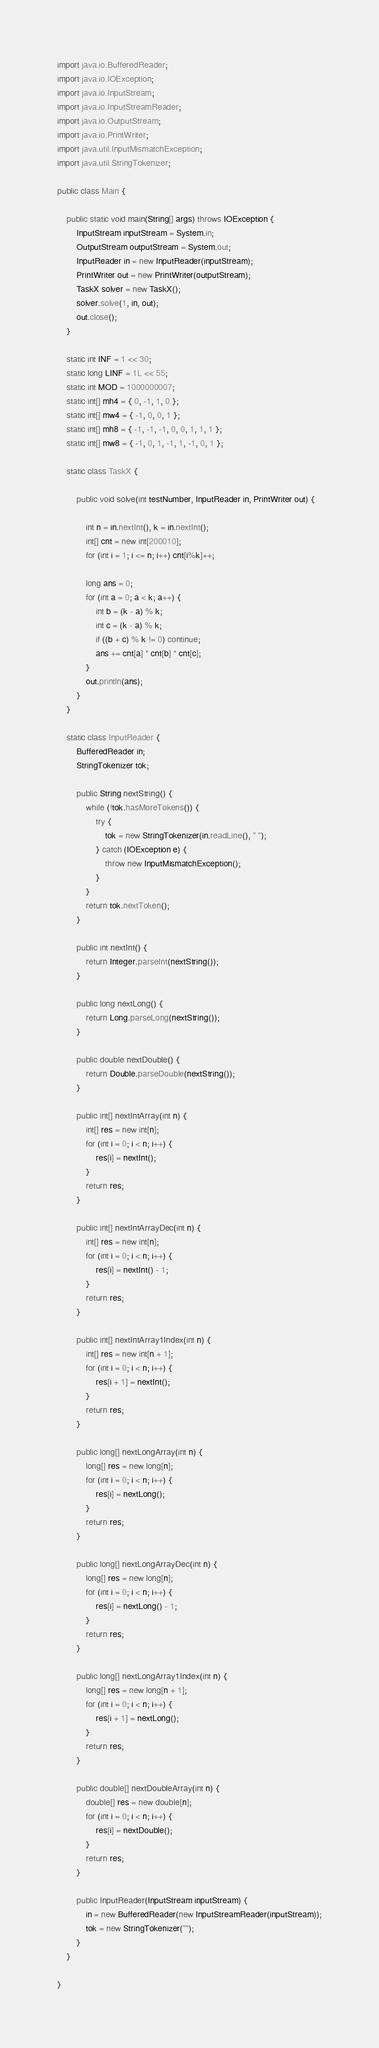<code> <loc_0><loc_0><loc_500><loc_500><_Java_>import java.io.BufferedReader;
import java.io.IOException;
import java.io.InputStream;
import java.io.InputStreamReader;
import java.io.OutputStream;
import java.io.PrintWriter;
import java.util.InputMismatchException;
import java.util.StringTokenizer;

public class Main {

	public static void main(String[] args) throws IOException {
		InputStream inputStream = System.in;
		OutputStream outputStream = System.out;
		InputReader in = new InputReader(inputStream);
		PrintWriter out = new PrintWriter(outputStream);
		TaskX solver = new TaskX();
		solver.solve(1, in, out);
		out.close();
	}

	static int INF = 1 << 30;
	static long LINF = 1L << 55;
	static int MOD = 1000000007;
	static int[] mh4 = { 0, -1, 1, 0 };
	static int[] mw4 = { -1, 0, 0, 1 };
	static int[] mh8 = { -1, -1, -1, 0, 0, 1, 1, 1 };
	static int[] mw8 = { -1, 0, 1, -1, 1, -1, 0, 1 };

	static class TaskX {

		public void solve(int testNumber, InputReader in, PrintWriter out) {

			int n = in.nextInt(), k = in.nextInt();
			int[] cnt = new int[200010];
			for (int i = 1; i <= n; i++) cnt[i%k]++;

			long ans = 0;
			for (int a = 0; a < k; a++) {
				int b = (k - a) % k;
				int c = (k - a) % k;
				if ((b + c) % k != 0) continue;
				ans += cnt[a] * cnt[b] * cnt[c];
			}
			out.println(ans);
		}
	}

	static class InputReader {
		BufferedReader in;
		StringTokenizer tok;

		public String nextString() {
			while (!tok.hasMoreTokens()) {
				try {
					tok = new StringTokenizer(in.readLine(), " ");
				} catch (IOException e) {
					throw new InputMismatchException();
				}
			}
			return tok.nextToken();
		}

		public int nextInt() {
			return Integer.parseInt(nextString());
		}

		public long nextLong() {
			return Long.parseLong(nextString());
		}

		public double nextDouble() {
			return Double.parseDouble(nextString());
		}

		public int[] nextIntArray(int n) {
			int[] res = new int[n];
			for (int i = 0; i < n; i++) {
				res[i] = nextInt();
			}
			return res;
		}

		public int[] nextIntArrayDec(int n) {
			int[] res = new int[n];
			for (int i = 0; i < n; i++) {
				res[i] = nextInt() - 1;
			}
			return res;
		}

		public int[] nextIntArray1Index(int n) {
			int[] res = new int[n + 1];
			for (int i = 0; i < n; i++) {
				res[i + 1] = nextInt();
			}
			return res;
		}

		public long[] nextLongArray(int n) {
			long[] res = new long[n];
			for (int i = 0; i < n; i++) {
				res[i] = nextLong();
			}
			return res;
		}

		public long[] nextLongArrayDec(int n) {
			long[] res = new long[n];
			for (int i = 0; i < n; i++) {
				res[i] = nextLong() - 1;
			}
			return res;
		}

		public long[] nextLongArray1Index(int n) {
			long[] res = new long[n + 1];
			for (int i = 0; i < n; i++) {
				res[i + 1] = nextLong();
			}
			return res;
		}

		public double[] nextDoubleArray(int n) {
			double[] res = new double[n];
			for (int i = 0; i < n; i++) {
				res[i] = nextDouble();
			}
			return res;
		}

		public InputReader(InputStream inputStream) {
			in = new BufferedReader(new InputStreamReader(inputStream));
			tok = new StringTokenizer("");
		}
	}

}
</code> 